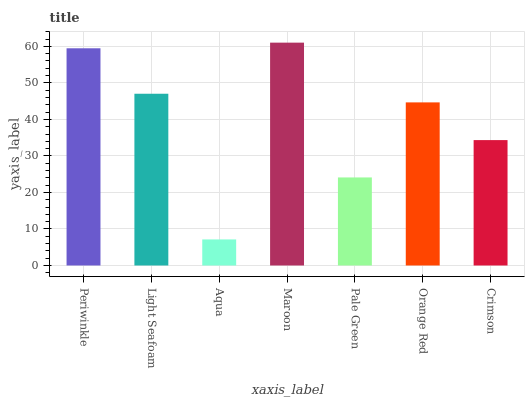Is Aqua the minimum?
Answer yes or no. Yes. Is Maroon the maximum?
Answer yes or no. Yes. Is Light Seafoam the minimum?
Answer yes or no. No. Is Light Seafoam the maximum?
Answer yes or no. No. Is Periwinkle greater than Light Seafoam?
Answer yes or no. Yes. Is Light Seafoam less than Periwinkle?
Answer yes or no. Yes. Is Light Seafoam greater than Periwinkle?
Answer yes or no. No. Is Periwinkle less than Light Seafoam?
Answer yes or no. No. Is Orange Red the high median?
Answer yes or no. Yes. Is Orange Red the low median?
Answer yes or no. Yes. Is Crimson the high median?
Answer yes or no. No. Is Periwinkle the low median?
Answer yes or no. No. 